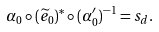Convert formula to latex. <formula><loc_0><loc_0><loc_500><loc_500>\alpha _ { 0 } \circ ( \widetilde { e } _ { 0 } ) ^ { * } \circ ( \alpha ^ { \prime } _ { 0 } ) ^ { - 1 } = s _ { d } .</formula> 